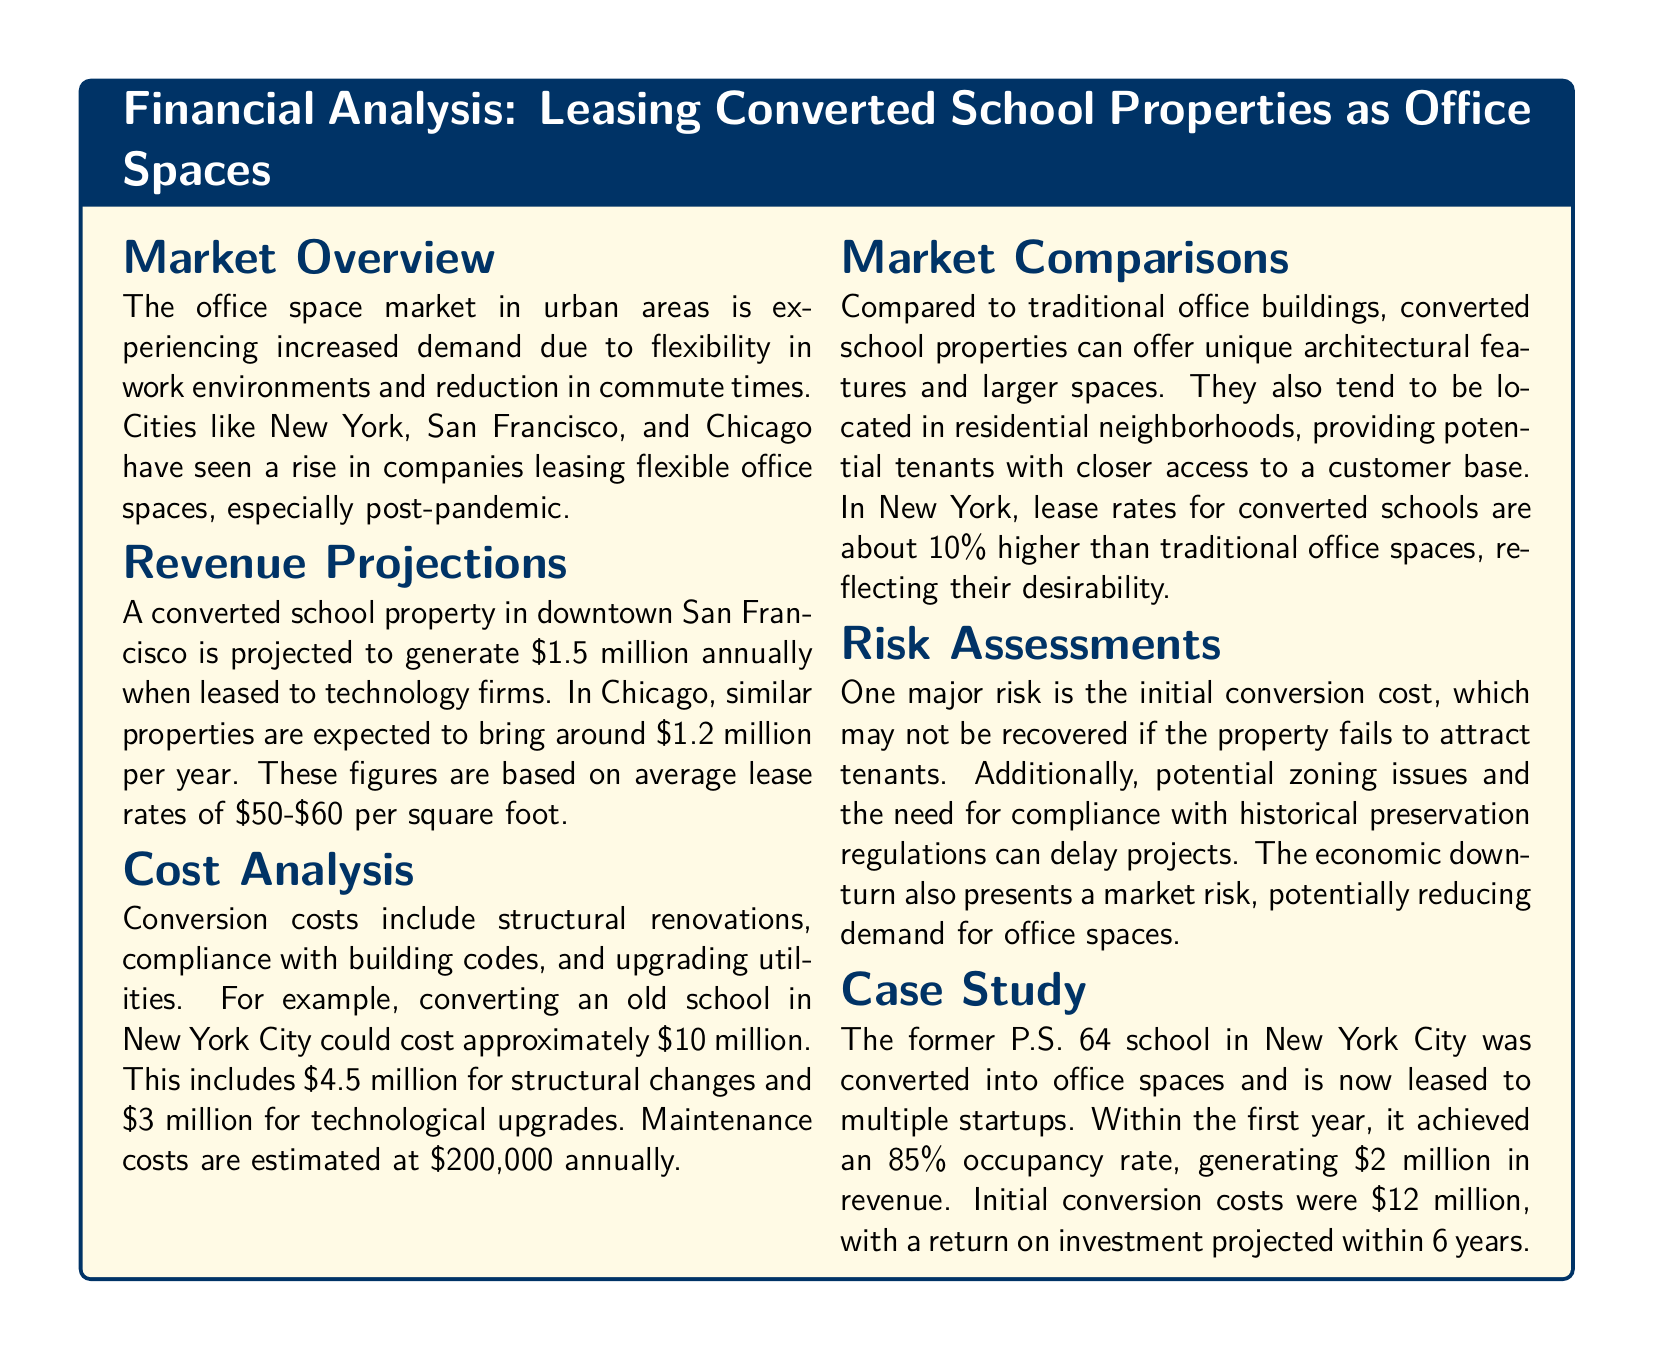what is the projected annual revenue for the converted school property in San Francisco? The document states that a converted school property in downtown San Francisco is projected to generate $1.5 million annually.
Answer: $1.5 million what is the cost for structural changes in the New York City conversion? The cost for structural changes mentioned in the document is $4.5 million.
Answer: $4.5 million how much maintenance cost is estimated annually? The estimated annual maintenance cost is stated as $200,000.
Answer: $200,000 what is the occupancy rate achieved by the former P.S. 64 school within the first year? The document mentions that the former P.S. 64 school achieved an occupancy rate of 85% within the first year.
Answer: 85% which city has a projected revenue of $1.2 million per year from converting school properties? The document specifies that properties in Chicago are expected to bring around $1.2 million per year.
Answer: Chicago what percentage higher are lease rates for converted schools compared to traditional office spaces in New York? The document indicates that lease rates for converted schools are about 10% higher than traditional office spaces.
Answer: 10% what is a major risk identified in the document regarding initial conversion costs? The document highlights that one major risk is that the initial conversion cost may not be recovered if the property fails to attract tenants.
Answer: initial conversion cost over how many years is a return on investment projected for the former P.S. 64 school? The return on investment for the former P.S. 64 school is projected within 6 years.
Answer: 6 years 